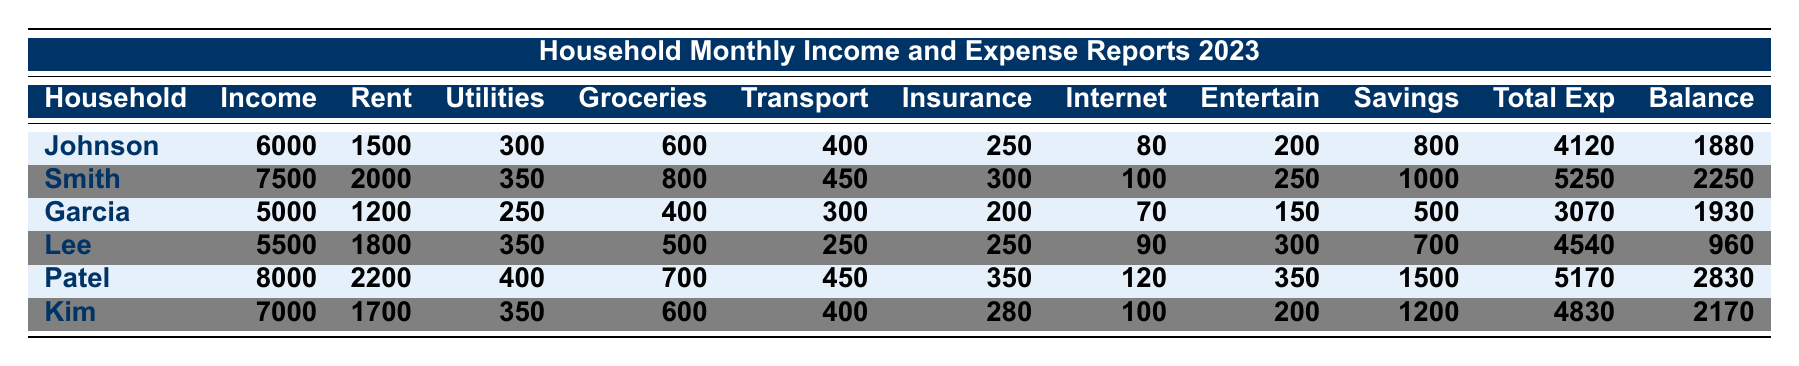What is the monthly income of The Patel Family? The Patel Family's monthly income is listed in the table, which states that their income is 8000.
Answer: 8000 How much does The Smith Family spend on groceries? The table provides the expenditure on groceries for The Smith Family, which is 800.
Answer: 800 Which household has the highest remaining balance? By comparing the remaining balance of all households, The Patel Family has the highest balance of 2830.
Answer: The Patel Family What is the total amount paid in rent by The Lee Family? The table shows that The Lee Family pays 1800 in rent.
Answer: 1800 How much are the total expenses for The Garcia Family? The table indicates that The Garcia Family's total expenses are 3070.
Answer: 3070 Which family spends the least on transportation? The transportation costs listed are compared: The Garcia Family spends 300, which is the least among all families.
Answer: The Garcia Family What is the average savings across all households? The savings for each household are 800, 1000, 500, 700, 1500, and 1200. The sum is 4700, and dividing by 6 households gives an average of 783.33.
Answer: 783.33 Is the total expense of The Kim Family less than 5000? The Kim Family's total expenses are 4830, which is less than 5000, confirming the statement as true.
Answer: Yes How does the remaining balance of The Johnson Family compare to The Lee Family? The Johnson Family has a remaining balance of 1880, while The Lee Family has 960. 1880 is greater than 960, indicating Johnson has a higher remaining balance.
Answer: Johnson Family has a higher remaining balance If all the families combined their monthly incomes, what would the total be? The monthly incomes are summed: 6000 + 7500 + 5000 + 5500 + 8000 + 7000 = 41000.
Answer: 41000 Which family has the highest expenditure on entertainment? The entertainment expenses are compared: The Patel Family spends 350 which is the highest reported in the table.
Answer: The Patel Family What is the difference in rent payment between The Patel Family and The Kim Family? The Patel Family pays 2200 in rent, and The Kim Family pays 1700. The difference is 2200 - 1700 = 500.
Answer: 500 